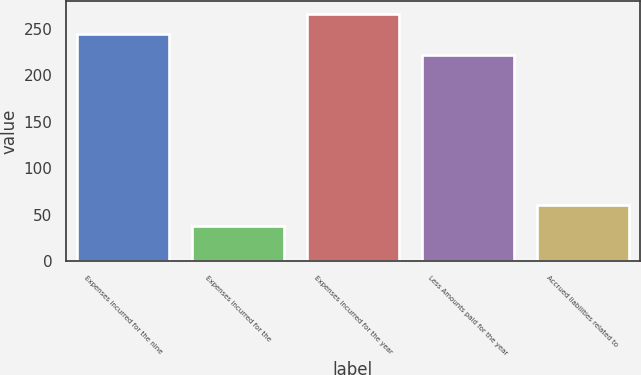Convert chart to OTSL. <chart><loc_0><loc_0><loc_500><loc_500><bar_chart><fcel>Expenses incurred for the nine<fcel>Expenses incurred for the<fcel>Expenses incurred for the year<fcel>Less Amounts paid for the year<fcel>Accrued liabilities related to<nl><fcel>244.3<fcel>38<fcel>266.6<fcel>222<fcel>60.3<nl></chart> 